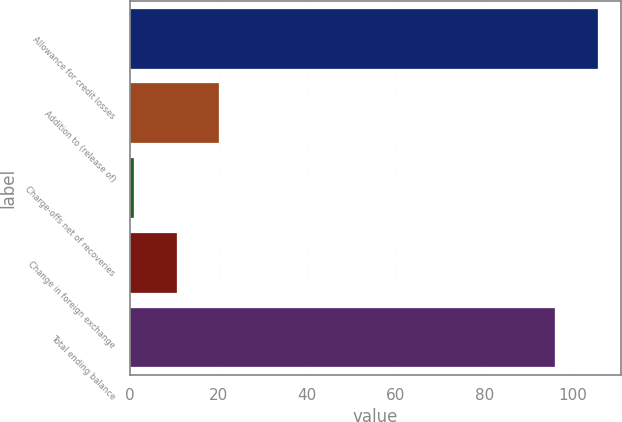Convert chart. <chart><loc_0><loc_0><loc_500><loc_500><bar_chart><fcel>Allowance for credit losses<fcel>Addition to (release of)<fcel>Charge-offs net of recoveries<fcel>Change in foreign exchange<fcel>Total ending balance<nl><fcel>105.6<fcel>20.2<fcel>1<fcel>10.6<fcel>96<nl></chart> 